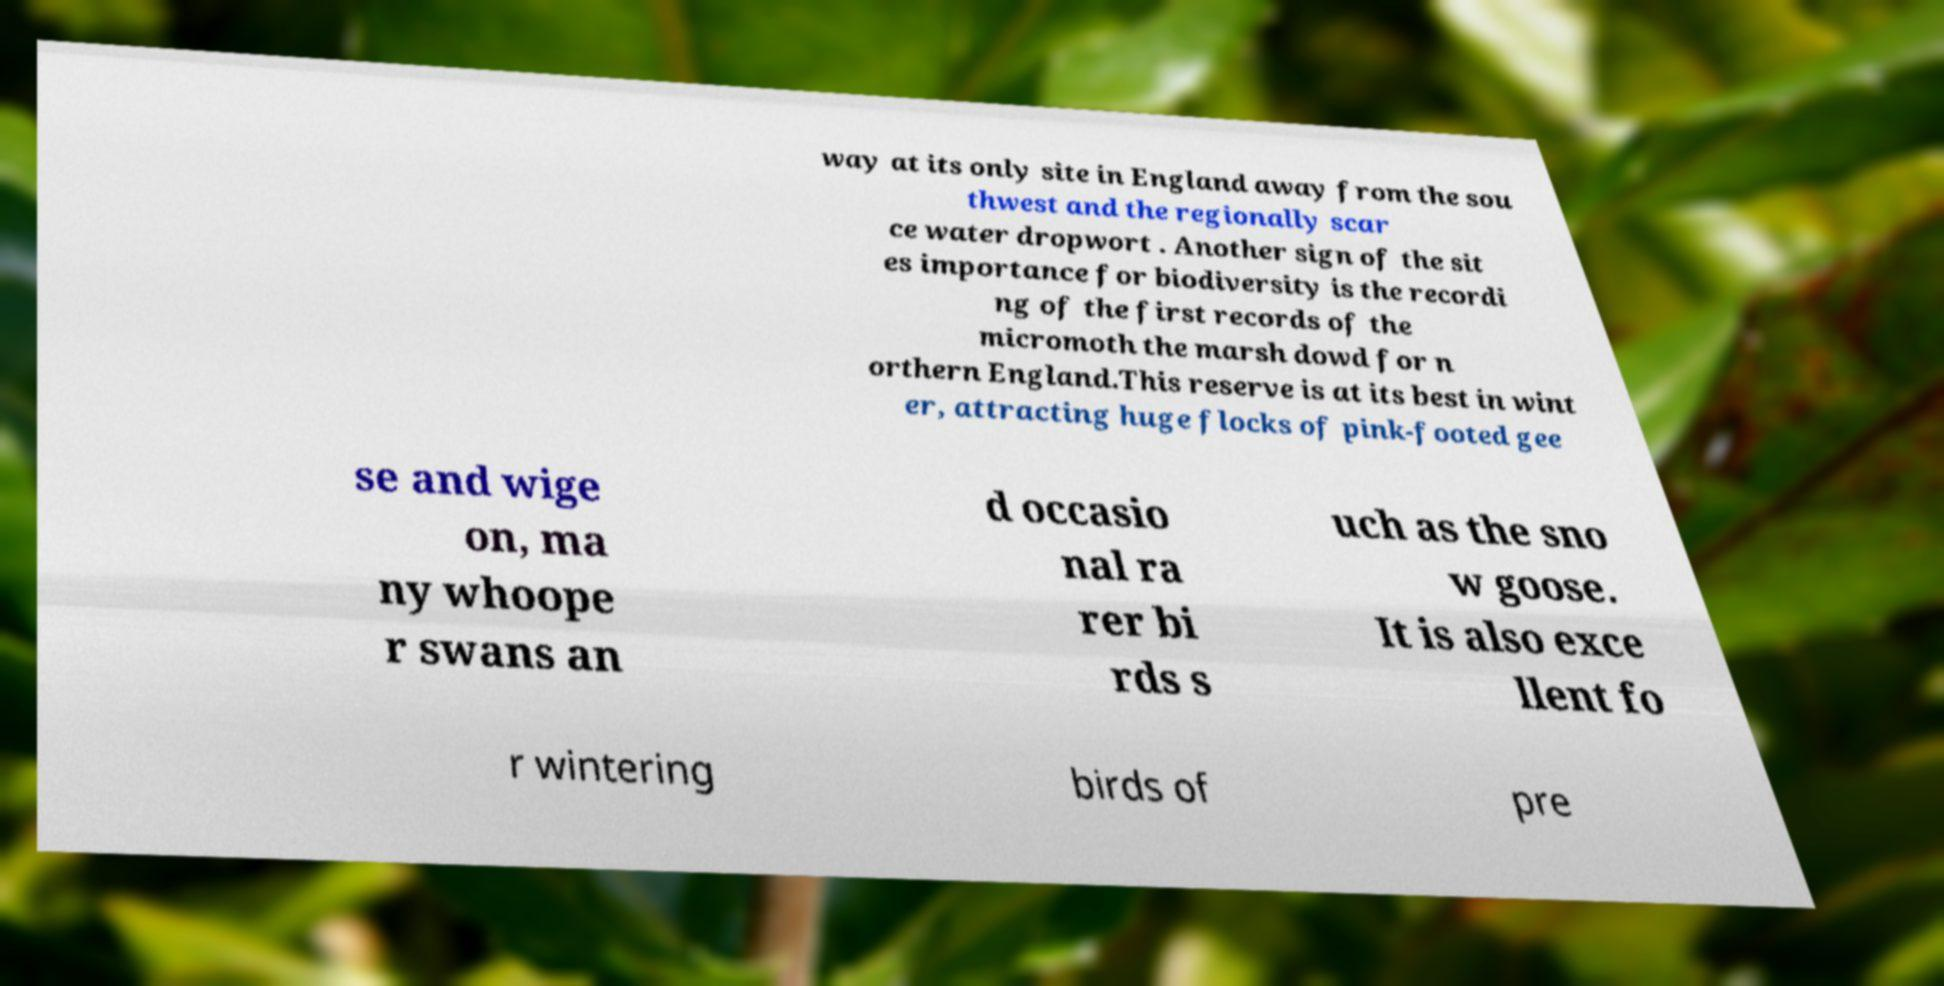Could you assist in decoding the text presented in this image and type it out clearly? way at its only site in England away from the sou thwest and the regionally scar ce water dropwort . Another sign of the sit es importance for biodiversity is the recordi ng of the first records of the micromoth the marsh dowd for n orthern England.This reserve is at its best in wint er, attracting huge flocks of pink-footed gee se and wige on, ma ny whoope r swans an d occasio nal ra rer bi rds s uch as the sno w goose. It is also exce llent fo r wintering birds of pre 